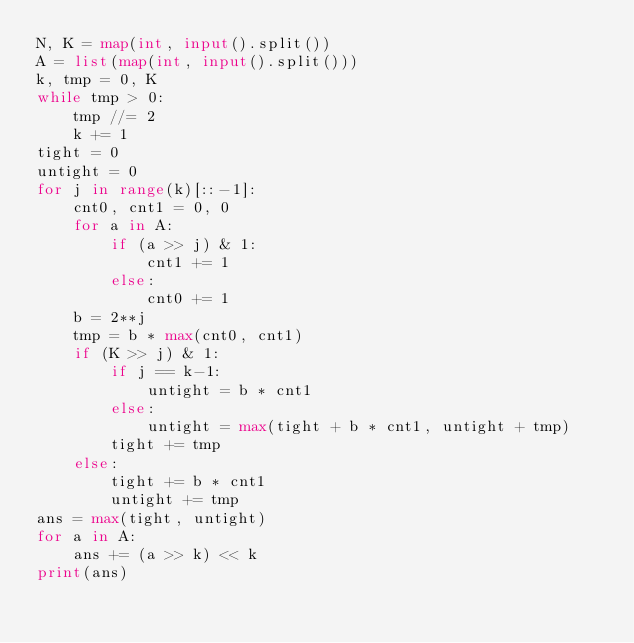Convert code to text. <code><loc_0><loc_0><loc_500><loc_500><_Python_>N, K = map(int, input().split())
A = list(map(int, input().split()))
k, tmp = 0, K
while tmp > 0:
    tmp //= 2
    k += 1
tight = 0
untight = 0
for j in range(k)[::-1]:
    cnt0, cnt1 = 0, 0
    for a in A:
        if (a >> j) & 1:
            cnt1 += 1
        else:
            cnt0 += 1
    b = 2**j
    tmp = b * max(cnt0, cnt1)
    if (K >> j) & 1:
        if j == k-1:
            untight = b * cnt1
        else:
            untight = max(tight + b * cnt1, untight + tmp)
        tight += tmp
    else:
        tight += b * cnt1
        untight += tmp
ans = max(tight, untight)
for a in A:
    ans += (a >> k) << k
print(ans)</code> 